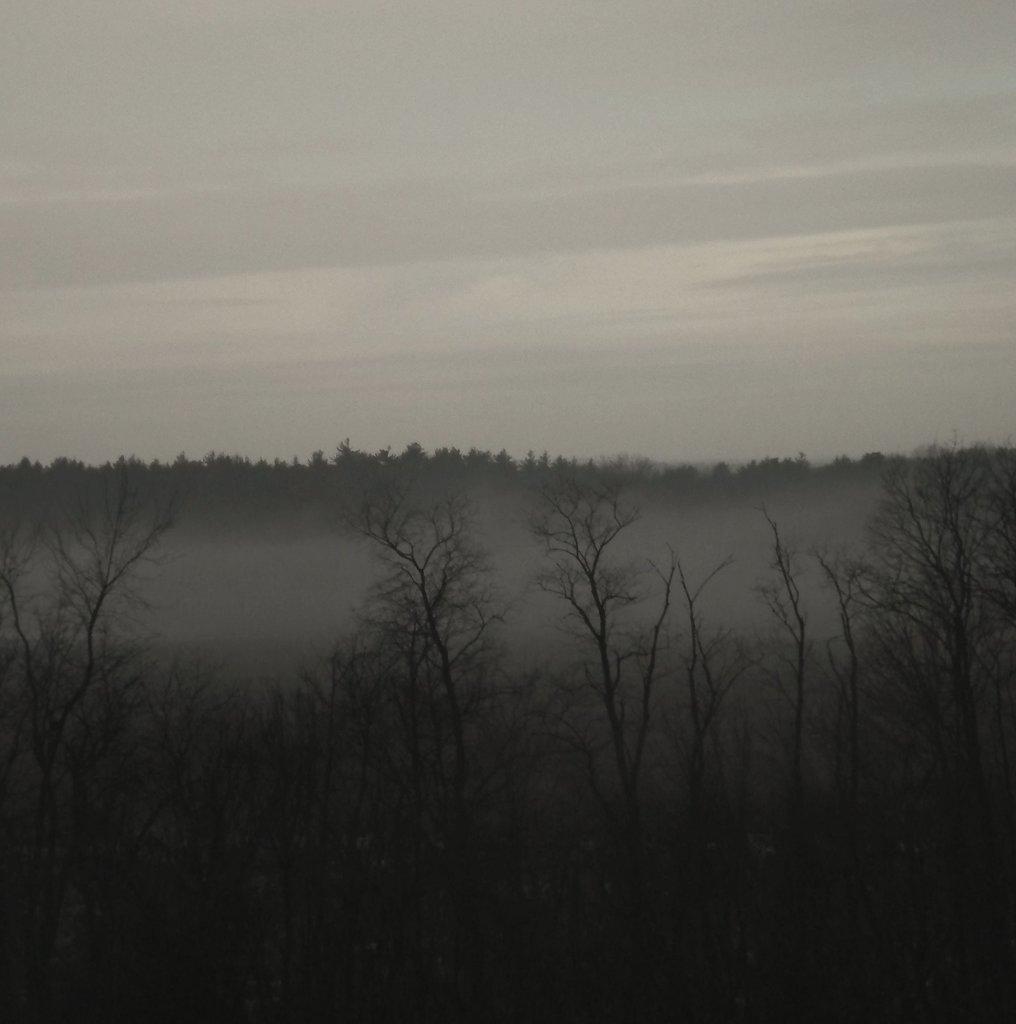How would you summarize this image in a sentence or two? In this image I can see trees. In the background I can see the sky. 